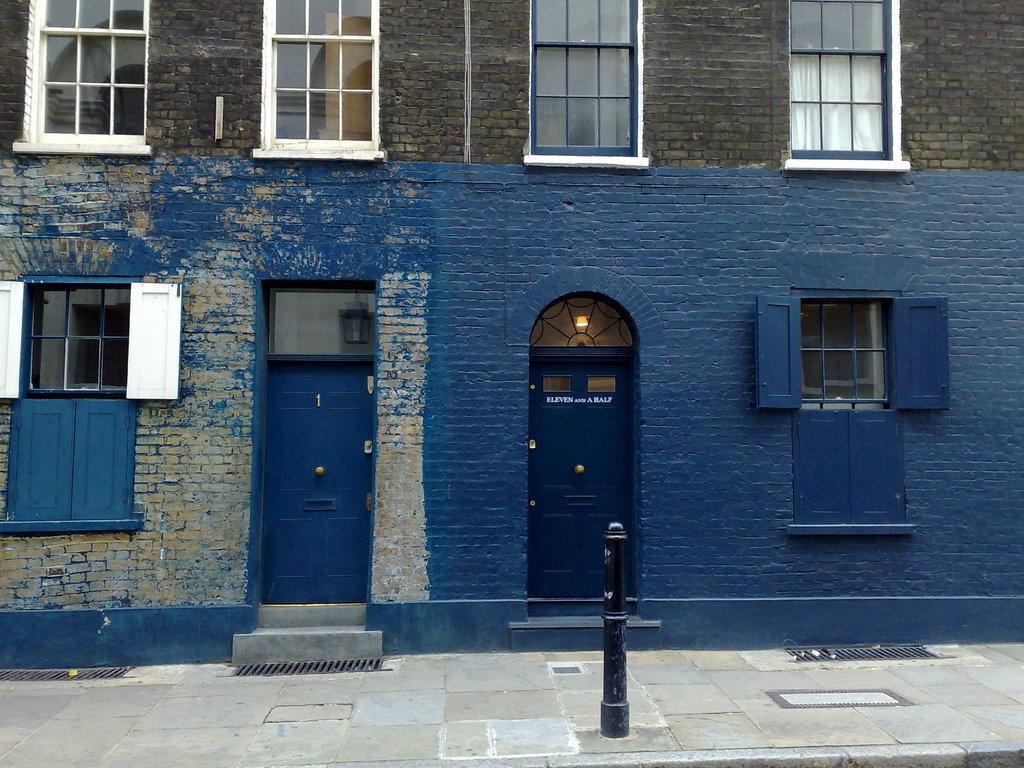Describe this image in one or two sentences. In this image I can see the building with windows and the doors. In-front of the building I can see black color pole. 